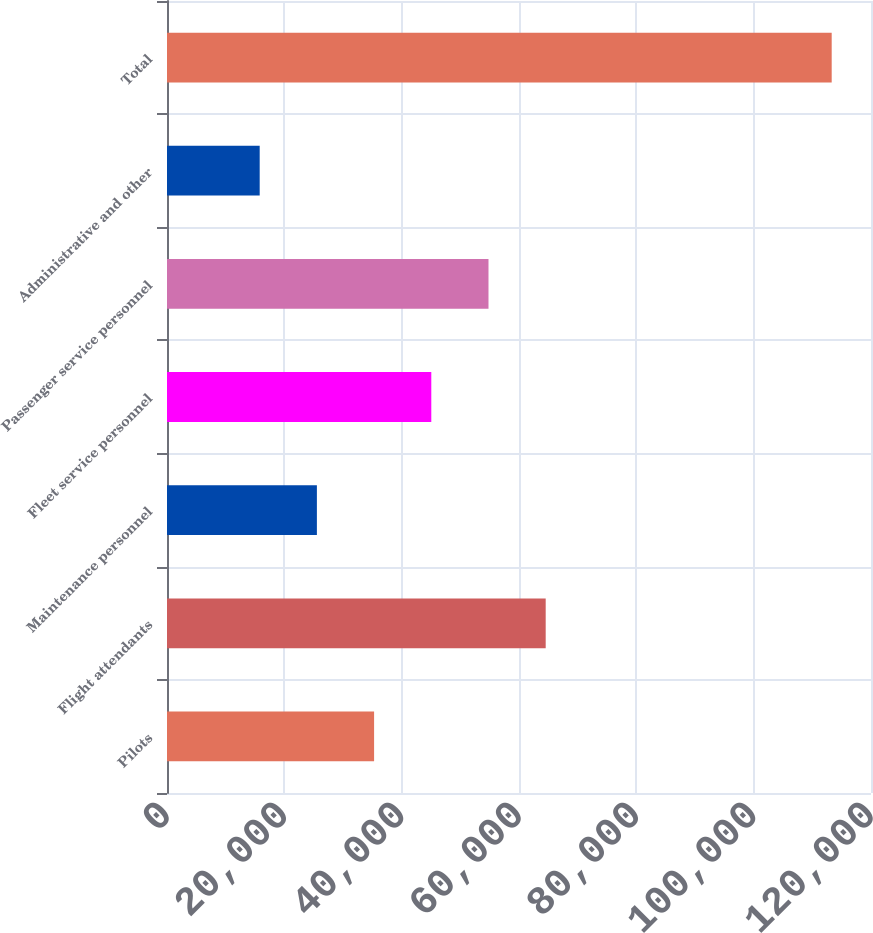Convert chart. <chart><loc_0><loc_0><loc_500><loc_500><bar_chart><fcel>Pilots<fcel>Flight attendants<fcel>Maintenance personnel<fcel>Fleet service personnel<fcel>Passenger service personnel<fcel>Administrative and other<fcel>Total<nl><fcel>35300<fcel>64550<fcel>25550<fcel>45050<fcel>54800<fcel>15800<fcel>113300<nl></chart> 